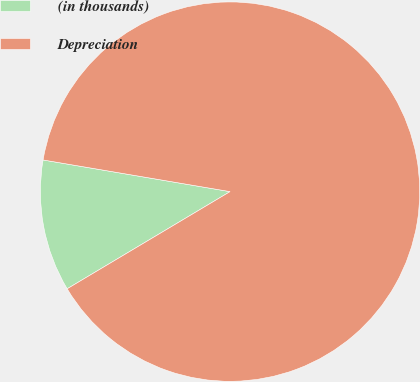Convert chart to OTSL. <chart><loc_0><loc_0><loc_500><loc_500><pie_chart><fcel>(in thousands)<fcel>Depreciation<nl><fcel>11.23%<fcel>88.77%<nl></chart> 